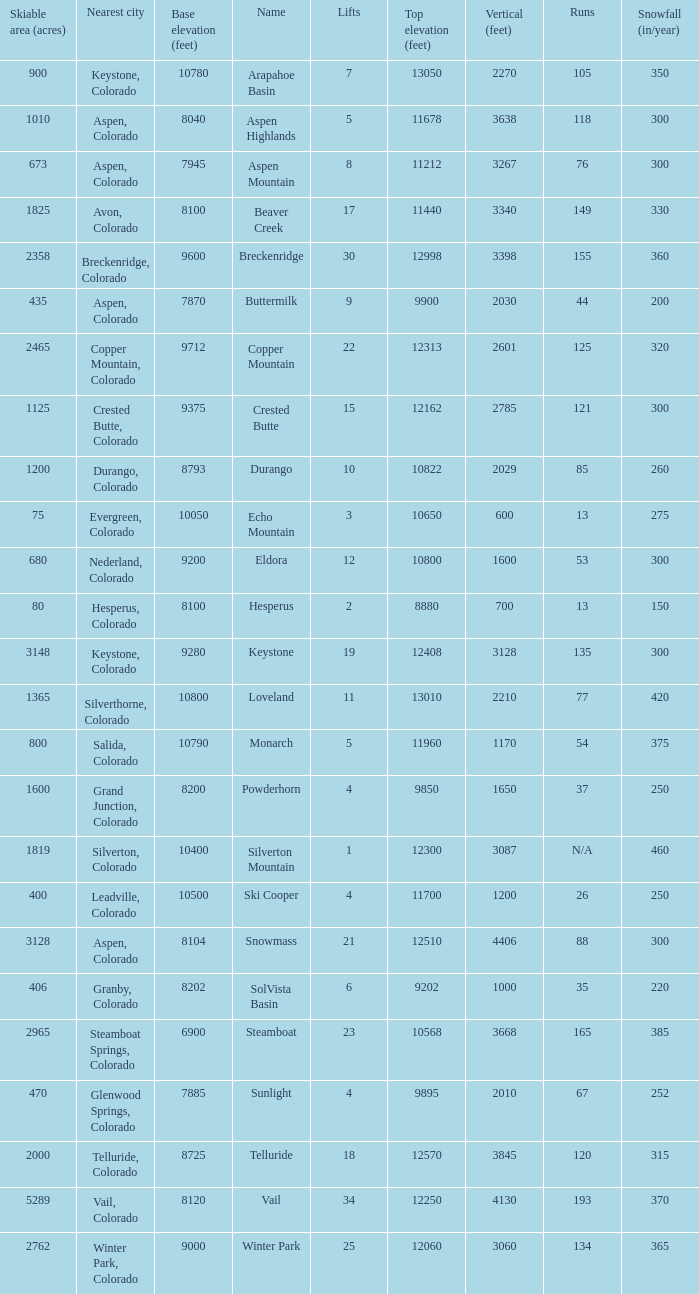What is the snowfall for ski resort Snowmass? 300.0. 